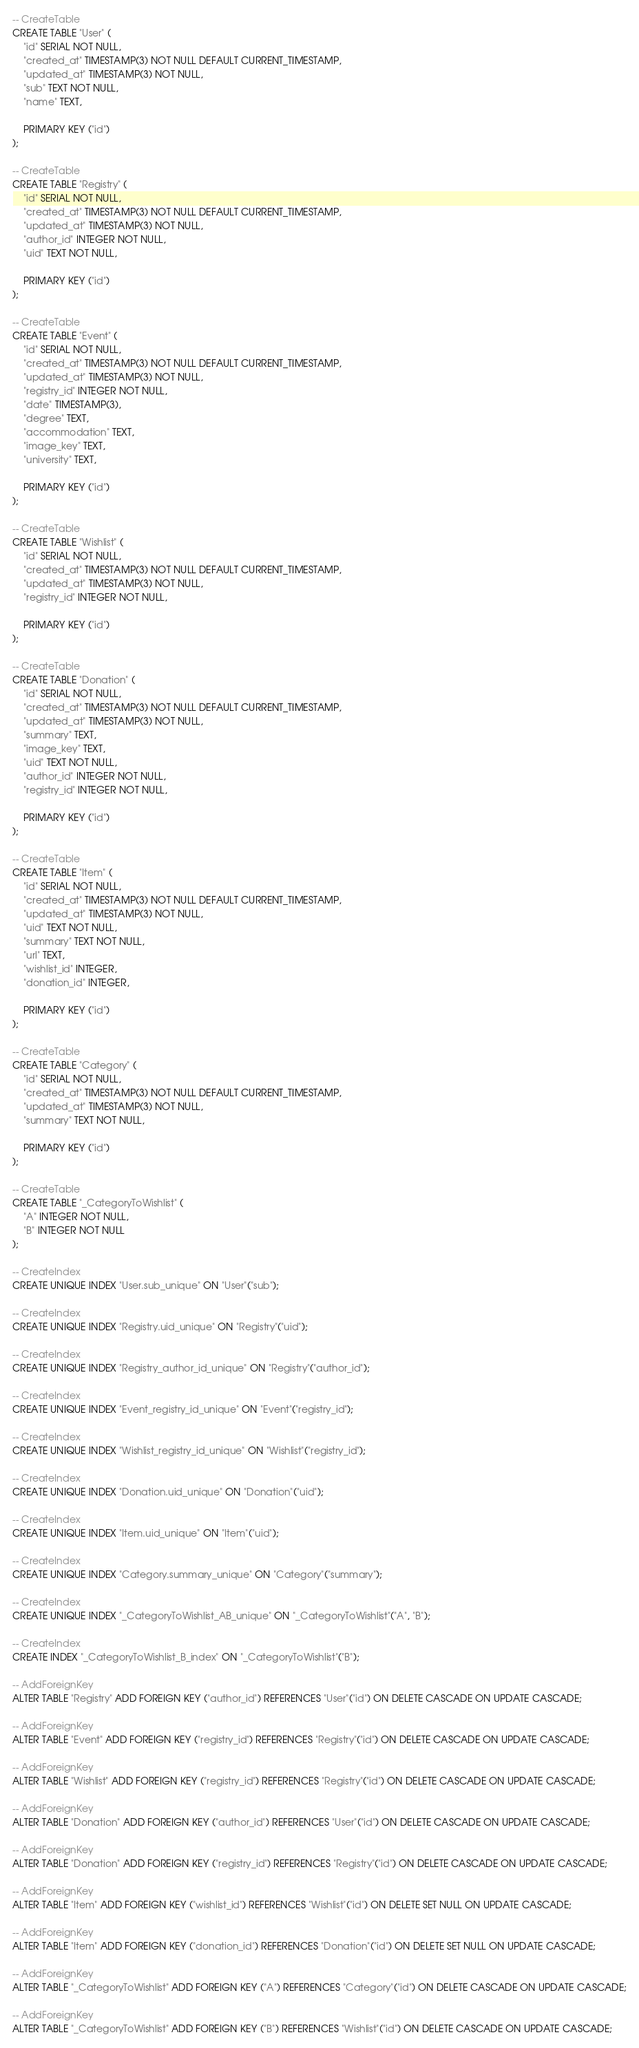Convert code to text. <code><loc_0><loc_0><loc_500><loc_500><_SQL_>-- CreateTable
CREATE TABLE "User" (
    "id" SERIAL NOT NULL,
    "created_at" TIMESTAMP(3) NOT NULL DEFAULT CURRENT_TIMESTAMP,
    "updated_at" TIMESTAMP(3) NOT NULL,
    "sub" TEXT NOT NULL,
    "name" TEXT,

    PRIMARY KEY ("id")
);

-- CreateTable
CREATE TABLE "Registry" (
    "id" SERIAL NOT NULL,
    "created_at" TIMESTAMP(3) NOT NULL DEFAULT CURRENT_TIMESTAMP,
    "updated_at" TIMESTAMP(3) NOT NULL,
    "author_id" INTEGER NOT NULL,
    "uid" TEXT NOT NULL,

    PRIMARY KEY ("id")
);

-- CreateTable
CREATE TABLE "Event" (
    "id" SERIAL NOT NULL,
    "created_at" TIMESTAMP(3) NOT NULL DEFAULT CURRENT_TIMESTAMP,
    "updated_at" TIMESTAMP(3) NOT NULL,
    "registry_id" INTEGER NOT NULL,
    "date" TIMESTAMP(3),
    "degree" TEXT,
    "accommodation" TEXT,
    "image_key" TEXT,
    "university" TEXT,

    PRIMARY KEY ("id")
);

-- CreateTable
CREATE TABLE "Wishlist" (
    "id" SERIAL NOT NULL,
    "created_at" TIMESTAMP(3) NOT NULL DEFAULT CURRENT_TIMESTAMP,
    "updated_at" TIMESTAMP(3) NOT NULL,
    "registry_id" INTEGER NOT NULL,

    PRIMARY KEY ("id")
);

-- CreateTable
CREATE TABLE "Donation" (
    "id" SERIAL NOT NULL,
    "created_at" TIMESTAMP(3) NOT NULL DEFAULT CURRENT_TIMESTAMP,
    "updated_at" TIMESTAMP(3) NOT NULL,
    "summary" TEXT,
    "image_key" TEXT,
    "uid" TEXT NOT NULL,
    "author_id" INTEGER NOT NULL,
    "registry_id" INTEGER NOT NULL,

    PRIMARY KEY ("id")
);

-- CreateTable
CREATE TABLE "Item" (
    "id" SERIAL NOT NULL,
    "created_at" TIMESTAMP(3) NOT NULL DEFAULT CURRENT_TIMESTAMP,
    "updated_at" TIMESTAMP(3) NOT NULL,
    "uid" TEXT NOT NULL,
    "summary" TEXT NOT NULL,
    "url" TEXT,
    "wishlist_id" INTEGER,
    "donation_id" INTEGER,

    PRIMARY KEY ("id")
);

-- CreateTable
CREATE TABLE "Category" (
    "id" SERIAL NOT NULL,
    "created_at" TIMESTAMP(3) NOT NULL DEFAULT CURRENT_TIMESTAMP,
    "updated_at" TIMESTAMP(3) NOT NULL,
    "summary" TEXT NOT NULL,

    PRIMARY KEY ("id")
);

-- CreateTable
CREATE TABLE "_CategoryToWishlist" (
    "A" INTEGER NOT NULL,
    "B" INTEGER NOT NULL
);

-- CreateIndex
CREATE UNIQUE INDEX "User.sub_unique" ON "User"("sub");

-- CreateIndex
CREATE UNIQUE INDEX "Registry.uid_unique" ON "Registry"("uid");

-- CreateIndex
CREATE UNIQUE INDEX "Registry_author_id_unique" ON "Registry"("author_id");

-- CreateIndex
CREATE UNIQUE INDEX "Event_registry_id_unique" ON "Event"("registry_id");

-- CreateIndex
CREATE UNIQUE INDEX "Wishlist_registry_id_unique" ON "Wishlist"("registry_id");

-- CreateIndex
CREATE UNIQUE INDEX "Donation.uid_unique" ON "Donation"("uid");

-- CreateIndex
CREATE UNIQUE INDEX "Item.uid_unique" ON "Item"("uid");

-- CreateIndex
CREATE UNIQUE INDEX "Category.summary_unique" ON "Category"("summary");

-- CreateIndex
CREATE UNIQUE INDEX "_CategoryToWishlist_AB_unique" ON "_CategoryToWishlist"("A", "B");

-- CreateIndex
CREATE INDEX "_CategoryToWishlist_B_index" ON "_CategoryToWishlist"("B");

-- AddForeignKey
ALTER TABLE "Registry" ADD FOREIGN KEY ("author_id") REFERENCES "User"("id") ON DELETE CASCADE ON UPDATE CASCADE;

-- AddForeignKey
ALTER TABLE "Event" ADD FOREIGN KEY ("registry_id") REFERENCES "Registry"("id") ON DELETE CASCADE ON UPDATE CASCADE;

-- AddForeignKey
ALTER TABLE "Wishlist" ADD FOREIGN KEY ("registry_id") REFERENCES "Registry"("id") ON DELETE CASCADE ON UPDATE CASCADE;

-- AddForeignKey
ALTER TABLE "Donation" ADD FOREIGN KEY ("author_id") REFERENCES "User"("id") ON DELETE CASCADE ON UPDATE CASCADE;

-- AddForeignKey
ALTER TABLE "Donation" ADD FOREIGN KEY ("registry_id") REFERENCES "Registry"("id") ON DELETE CASCADE ON UPDATE CASCADE;

-- AddForeignKey
ALTER TABLE "Item" ADD FOREIGN KEY ("wishlist_id") REFERENCES "Wishlist"("id") ON DELETE SET NULL ON UPDATE CASCADE;

-- AddForeignKey
ALTER TABLE "Item" ADD FOREIGN KEY ("donation_id") REFERENCES "Donation"("id") ON DELETE SET NULL ON UPDATE CASCADE;

-- AddForeignKey
ALTER TABLE "_CategoryToWishlist" ADD FOREIGN KEY ("A") REFERENCES "Category"("id") ON DELETE CASCADE ON UPDATE CASCADE;

-- AddForeignKey
ALTER TABLE "_CategoryToWishlist" ADD FOREIGN KEY ("B") REFERENCES "Wishlist"("id") ON DELETE CASCADE ON UPDATE CASCADE;
</code> 